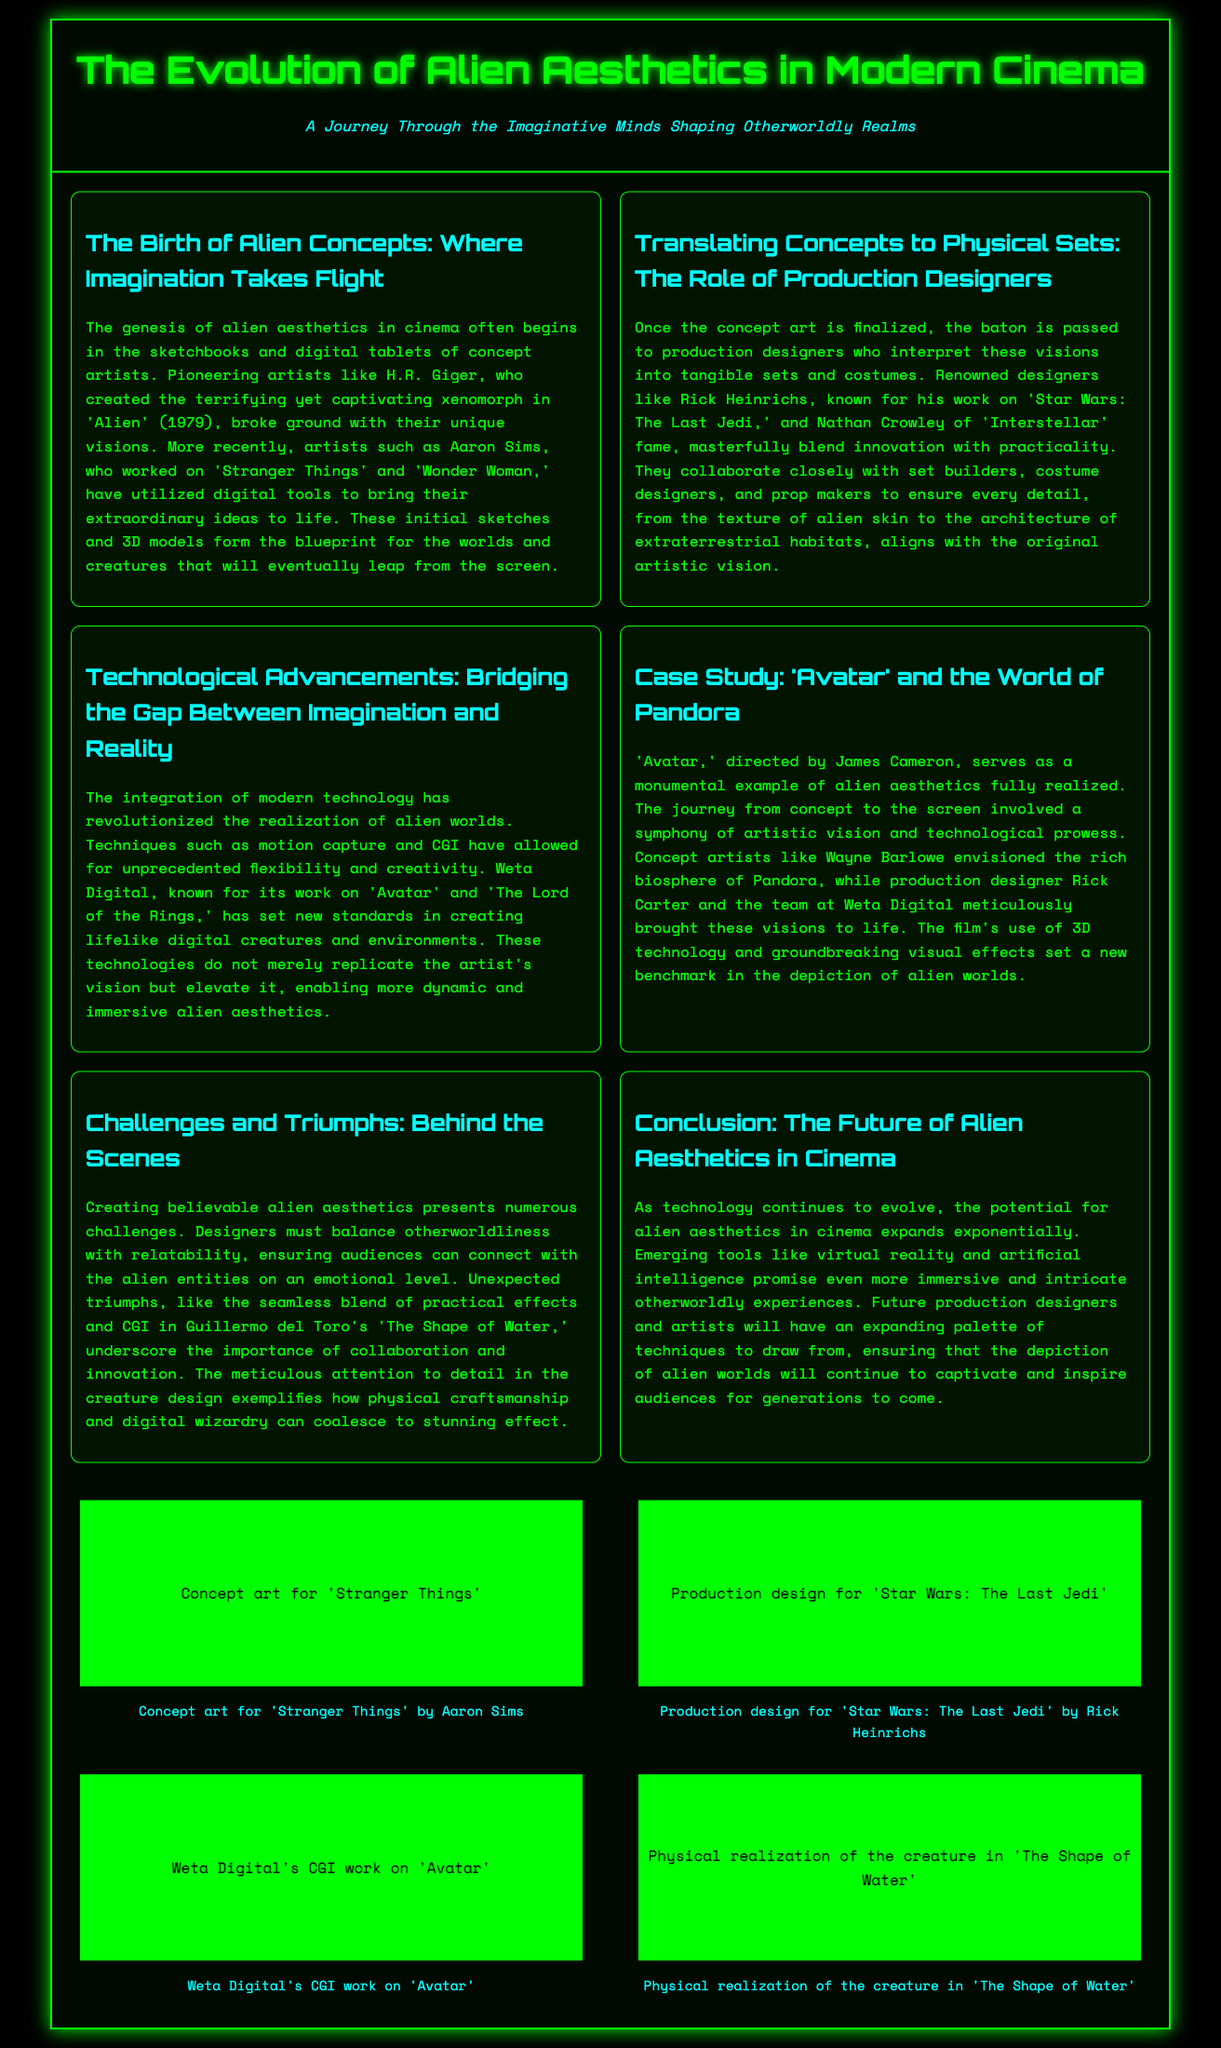What is the title of the document? The title of the document is presented prominently at the top, which is "The Evolution of Alien Aesthetics in Modern Cinema".
Answer: The Evolution of Alien Aesthetics in Modern Cinema Who created the xenomorph in 'Alien'? The document mentions H.R. Giger as the artist behind the xenomorph design in 'Alien'.
Answer: H.R. Giger Which artist worked on 'Stranger Things'? Aaron Sims is noted for his work on 'Stranger Things' as a concept artist.
Answer: Aaron Sims What year was 'Alien' released? The document states that 'Alien' was released in 1979.
Answer: 1979 Who is known for the production design of 'Star Wars: The Last Jedi'? The production designer noted for 'Star Wars: The Last Jedi' is Rick Heinrichs.
Answer: Rick Heinrichs What is a key technological advancement mentioned that aids in alien aesthetics? Motion capture is cited as one of the technological advancements that bridge imagination and reality.
Answer: Motion capture Which film is used as a case study for alien aesthetics? The document specifies 'Avatar' as a monumental example in the case study on alien aesthetics.
Answer: Avatar What is the future potential for alien aesthetics according to the document? The text suggests that emerging tools like virtual reality and artificial intelligence promise more immersive experiences.
Answer: Virtual reality and artificial intelligence What color theme dominates the document's layout? The overall color theme includes a black background with green text and accents, creating a sci-fi ambiance.
Answer: Black and green 